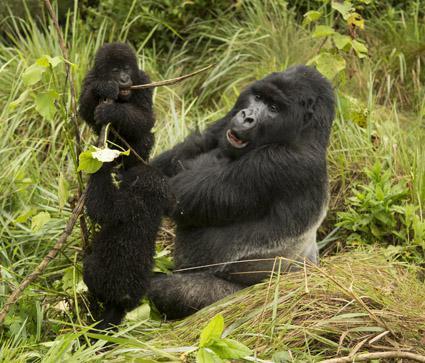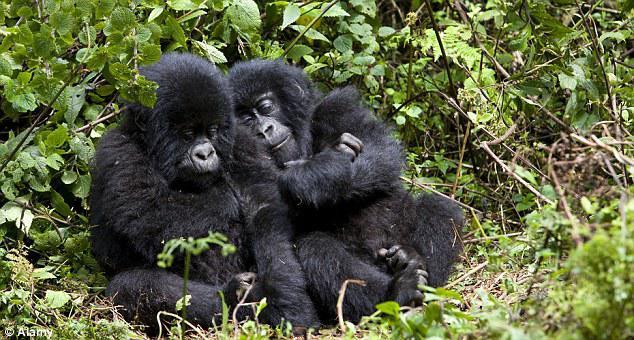The first image is the image on the left, the second image is the image on the right. For the images displayed, is the sentence "An image with no more than three gorillas shows an adult sitting behind a small juvenile ape." factually correct? Answer yes or no. Yes. The first image is the image on the left, the second image is the image on the right. For the images displayed, is the sentence "There are exactly two animals in the image on the right." factually correct? Answer yes or no. No. 